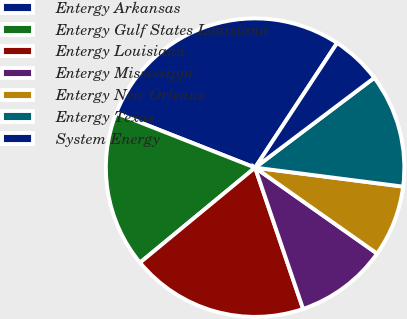Convert chart. <chart><loc_0><loc_0><loc_500><loc_500><pie_chart><fcel>Entergy Arkansas<fcel>Entergy Gulf States Louisiana<fcel>Entergy Louisiana<fcel>Entergy Mississippi<fcel>Entergy New Orleans<fcel>Entergy Texas<fcel>System Energy<nl><fcel>28.29%<fcel>16.95%<fcel>19.23%<fcel>10.02%<fcel>7.74%<fcel>12.31%<fcel>5.46%<nl></chart> 